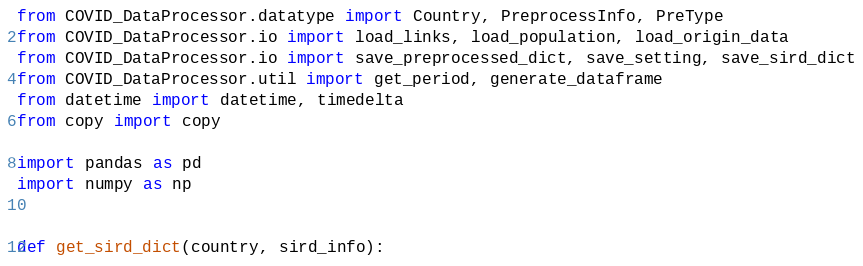Convert code to text. <code><loc_0><loc_0><loc_500><loc_500><_Python_>from COVID_DataProcessor.datatype import Country, PreprocessInfo, PreType
from COVID_DataProcessor.io import load_links, load_population, load_origin_data
from COVID_DataProcessor.io import save_preprocessed_dict, save_setting, save_sird_dict
from COVID_DataProcessor.util import get_period, generate_dataframe
from datetime import datetime, timedelta
from copy import copy

import pandas as pd
import numpy as np


def get_sird_dict(country, sird_info):</code> 